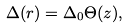<formula> <loc_0><loc_0><loc_500><loc_500>\Delta ( { r } ) = \Delta _ { 0 } \Theta ( z ) ,</formula> 